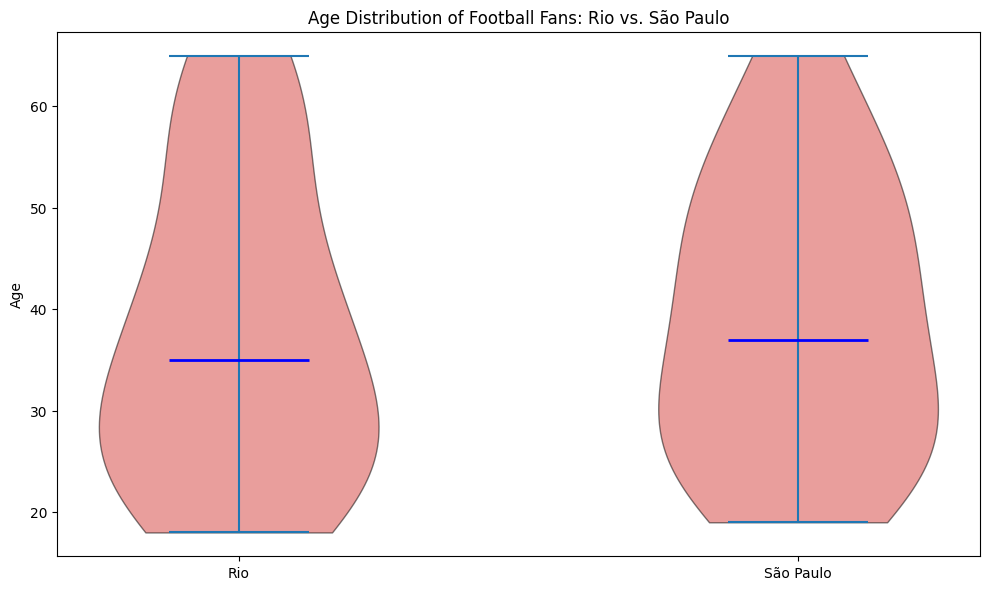What is the median age of football fans in Rio? To find the median age of football fans in Rio, locate the central value in the Rio distribution, indicated by the blue line within the violin plot for Rio.
Answer: 32 Comparing Rio and São Paulo, which city has a higher median age of football fans? Look for the blue lines within the violin plots of each city. The position of the blue line within São Paulo's distribution is higher compared to Rio's.
Answer: São Paulo Which city displays a wider age range of football fans? Assess the spread of the distributions for both cities. Rio's distribution spans from 18 to 65, while São Paulo's also ranges from 19 to 65, suggesting similar spreads.
Answer: Both Is there a color difference marking any specific values within the plots? The violin plot bodies are colored red, and the median lines are marked in blue, distinguishing the median values specifically.
Answer: Yes, red with blue median lines In which city is the interquartile range (IQR) of fan ages larger? Visually estimate the IQR as the spread around the most concentrated area of the distribution. São Paulo's distribution seems narrower in the middle compared to Rio, indicating a smaller IQR.
Answer: Rio Among the two cities, which city has a more varied distribution of football fan ages? The violin plot for Rio exhibits a larger spread, suggesting a more varied age distribution compared to São Paulo.
Answer: Rio How can you tell where the most common ages lie in these plots? The density of the distribution (thicker parts of the violin plots) indicates where most ages are common. For both cities, the middle portions represent the most common ages.
Answer: Thicker sections of the plots Considering the colors used in the plot, what do the black edges represent? The black edges outline the shape of the distribution, highlighting its entire range and the overall distribution pattern.
Answer: Distribution outlines 